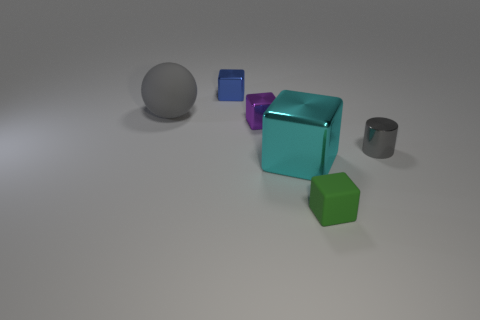Add 2 green objects. How many objects exist? 8 Subtract all blue metallic blocks. How many blocks are left? 3 Subtract all cyan cubes. How many cubes are left? 3 Subtract 4 cubes. How many cubes are left? 0 Subtract all blocks. How many objects are left? 2 Subtract all large gray cubes. Subtract all cubes. How many objects are left? 2 Add 1 gray balls. How many gray balls are left? 2 Add 1 large green cylinders. How many large green cylinders exist? 1 Subtract 0 cyan balls. How many objects are left? 6 Subtract all purple cylinders. Subtract all red cubes. How many cylinders are left? 1 